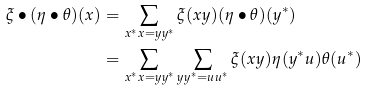<formula> <loc_0><loc_0><loc_500><loc_500>\xi \bullet ( \eta \bullet \theta ) ( x ) & = \sum _ { x ^ { * } x = y y ^ { * } } \xi ( x y ) ( \eta \bullet \theta ) ( y ^ { * } ) \\ & = \sum _ { x ^ { * } x = y y ^ { * } } \sum _ { y y ^ { * } = u u ^ { * } } \xi ( x y ) \eta ( y ^ { * } u ) \theta ( u ^ { * } )</formula> 